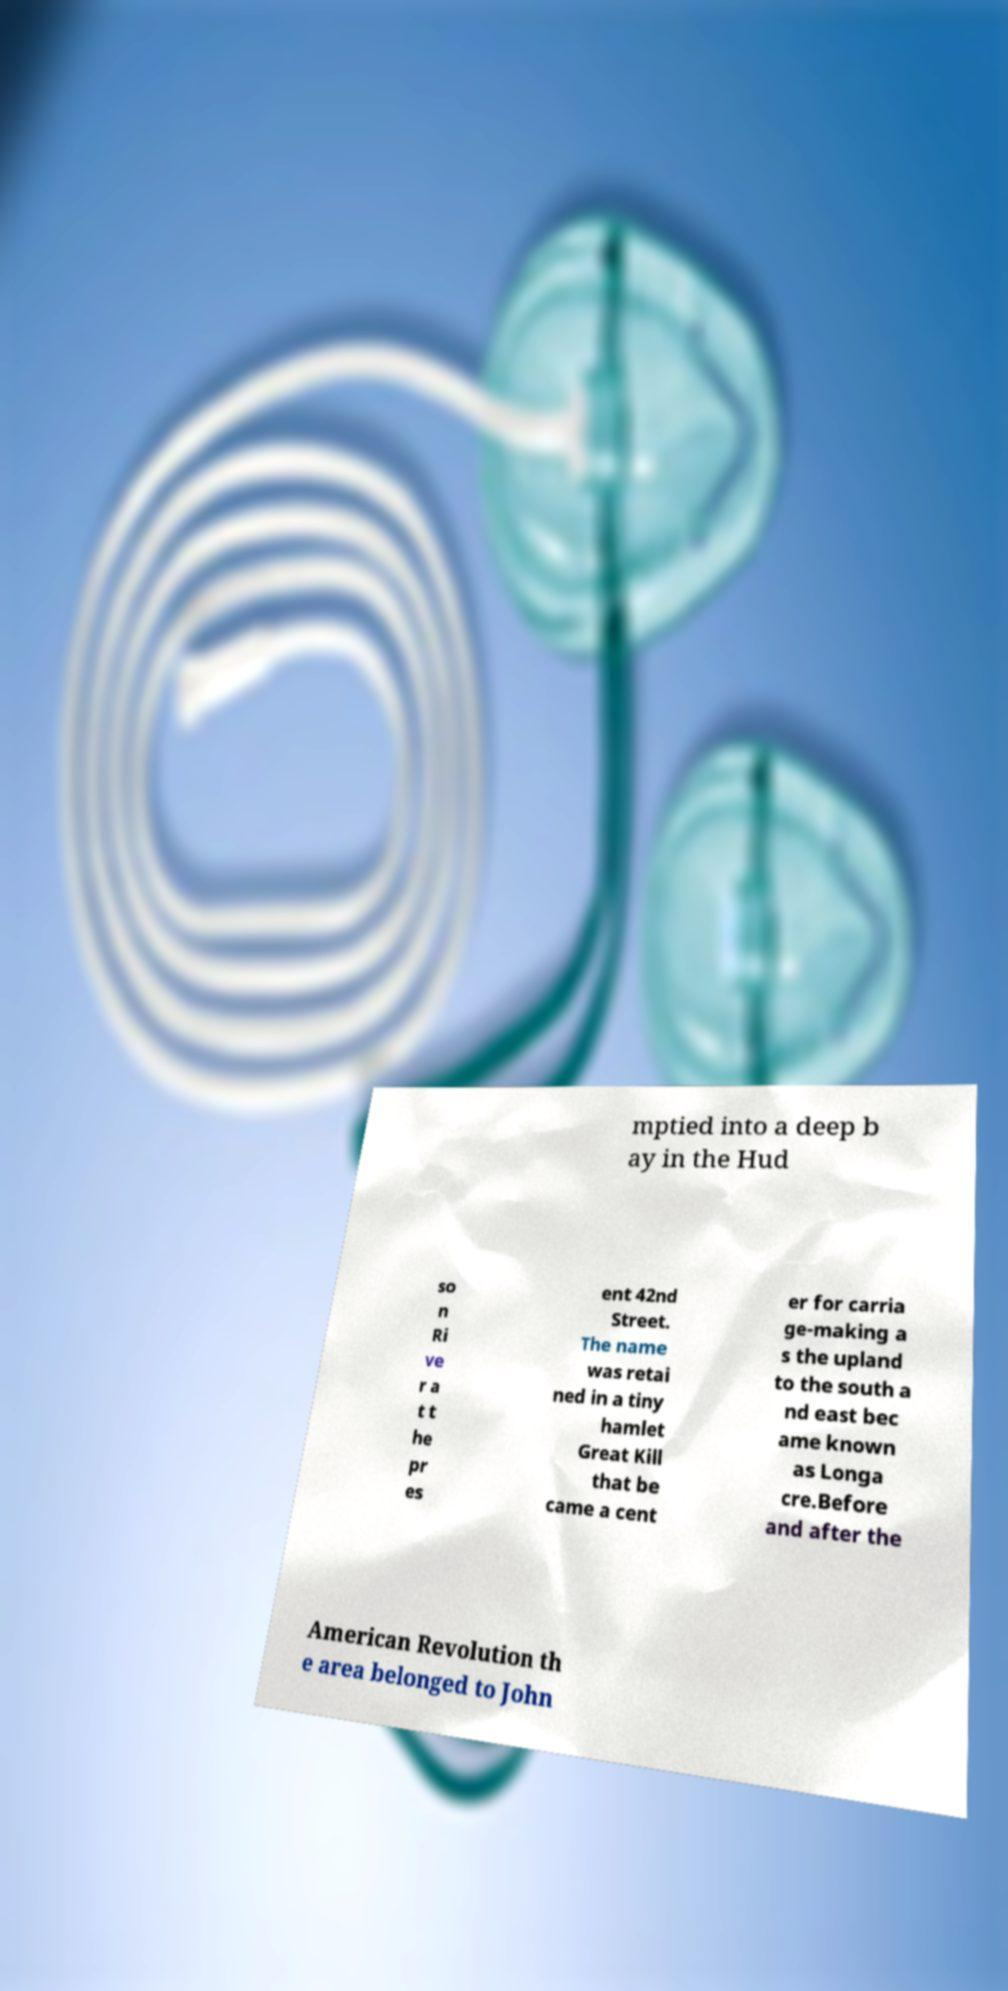For documentation purposes, I need the text within this image transcribed. Could you provide that? mptied into a deep b ay in the Hud so n Ri ve r a t t he pr es ent 42nd Street. The name was retai ned in a tiny hamlet Great Kill that be came a cent er for carria ge-making a s the upland to the south a nd east bec ame known as Longa cre.Before and after the American Revolution th e area belonged to John 